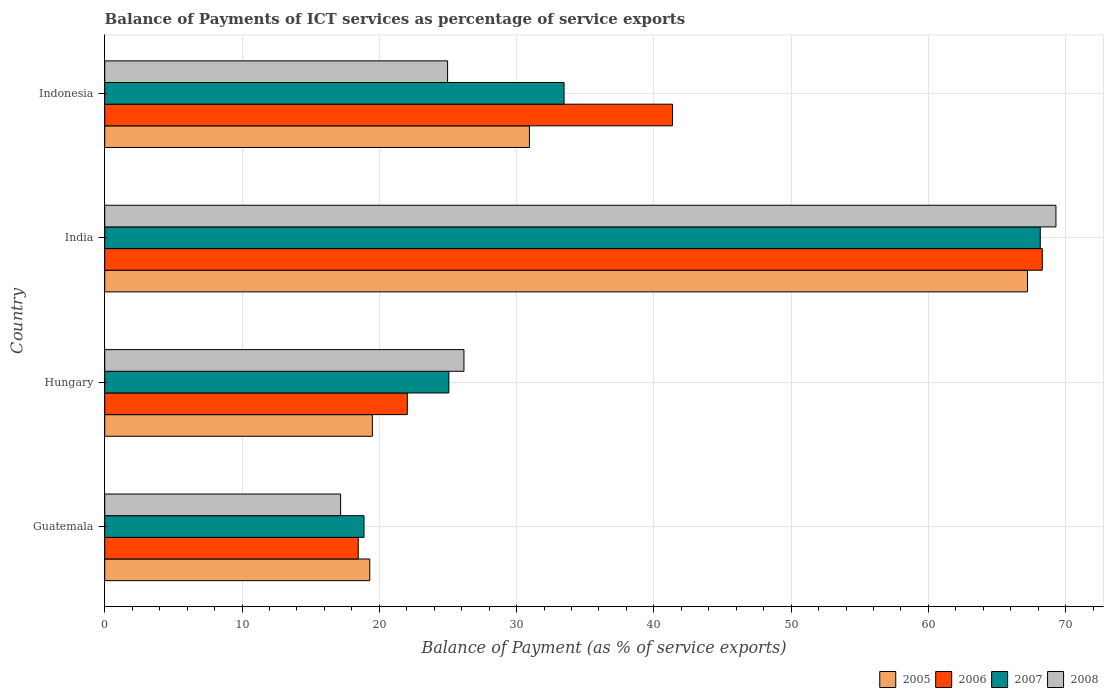How many groups of bars are there?
Provide a succinct answer. 4. Are the number of bars per tick equal to the number of legend labels?
Your response must be concise. Yes. Are the number of bars on each tick of the Y-axis equal?
Provide a short and direct response. Yes. How many bars are there on the 4th tick from the top?
Provide a short and direct response. 4. What is the label of the 2nd group of bars from the top?
Give a very brief answer. India. In how many cases, is the number of bars for a given country not equal to the number of legend labels?
Ensure brevity in your answer.  0. What is the balance of payments of ICT services in 2005 in Indonesia?
Make the answer very short. 30.94. Across all countries, what is the maximum balance of payments of ICT services in 2005?
Give a very brief answer. 67.22. Across all countries, what is the minimum balance of payments of ICT services in 2008?
Make the answer very short. 17.18. In which country was the balance of payments of ICT services in 2005 maximum?
Make the answer very short. India. In which country was the balance of payments of ICT services in 2008 minimum?
Your answer should be compact. Guatemala. What is the total balance of payments of ICT services in 2006 in the graph?
Your response must be concise. 150.17. What is the difference between the balance of payments of ICT services in 2007 in Hungary and that in India?
Ensure brevity in your answer.  -43.08. What is the difference between the balance of payments of ICT services in 2005 in India and the balance of payments of ICT services in 2007 in Guatemala?
Offer a very short reply. 48.33. What is the average balance of payments of ICT services in 2006 per country?
Provide a short and direct response. 37.54. What is the difference between the balance of payments of ICT services in 2007 and balance of payments of ICT services in 2005 in Indonesia?
Offer a very short reply. 2.52. What is the ratio of the balance of payments of ICT services in 2006 in Hungary to that in Indonesia?
Provide a succinct answer. 0.53. Is the balance of payments of ICT services in 2008 in Guatemala less than that in India?
Provide a short and direct response. Yes. What is the difference between the highest and the second highest balance of payments of ICT services in 2006?
Ensure brevity in your answer.  26.93. What is the difference between the highest and the lowest balance of payments of ICT services in 2008?
Your response must be concise. 52.11. In how many countries, is the balance of payments of ICT services in 2008 greater than the average balance of payments of ICT services in 2008 taken over all countries?
Ensure brevity in your answer.  1. What does the 2nd bar from the top in Indonesia represents?
Ensure brevity in your answer.  2007. How many bars are there?
Give a very brief answer. 16. How many countries are there in the graph?
Your answer should be compact. 4. What is the difference between two consecutive major ticks on the X-axis?
Your response must be concise. 10. Are the values on the major ticks of X-axis written in scientific E-notation?
Make the answer very short. No. Does the graph contain any zero values?
Your response must be concise. No. Where does the legend appear in the graph?
Ensure brevity in your answer.  Bottom right. How many legend labels are there?
Provide a succinct answer. 4. What is the title of the graph?
Make the answer very short. Balance of Payments of ICT services as percentage of service exports. Does "1979" appear as one of the legend labels in the graph?
Provide a succinct answer. No. What is the label or title of the X-axis?
Give a very brief answer. Balance of Payment (as % of service exports). What is the label or title of the Y-axis?
Offer a very short reply. Country. What is the Balance of Payment (as % of service exports) in 2005 in Guatemala?
Your answer should be compact. 19.31. What is the Balance of Payment (as % of service exports) in 2006 in Guatemala?
Give a very brief answer. 18.47. What is the Balance of Payment (as % of service exports) of 2007 in Guatemala?
Offer a very short reply. 18.89. What is the Balance of Payment (as % of service exports) of 2008 in Guatemala?
Give a very brief answer. 17.18. What is the Balance of Payment (as % of service exports) of 2005 in Hungary?
Ensure brevity in your answer.  19.5. What is the Balance of Payment (as % of service exports) in 2006 in Hungary?
Your response must be concise. 22.04. What is the Balance of Payment (as % of service exports) in 2007 in Hungary?
Provide a short and direct response. 25.07. What is the Balance of Payment (as % of service exports) of 2008 in Hungary?
Make the answer very short. 26.17. What is the Balance of Payment (as % of service exports) in 2005 in India?
Your answer should be compact. 67.22. What is the Balance of Payment (as % of service exports) in 2006 in India?
Your answer should be compact. 68.29. What is the Balance of Payment (as % of service exports) of 2007 in India?
Provide a short and direct response. 68.15. What is the Balance of Payment (as % of service exports) of 2008 in India?
Offer a terse response. 69.29. What is the Balance of Payment (as % of service exports) in 2005 in Indonesia?
Your answer should be compact. 30.94. What is the Balance of Payment (as % of service exports) of 2006 in Indonesia?
Keep it short and to the point. 41.36. What is the Balance of Payment (as % of service exports) of 2007 in Indonesia?
Your response must be concise. 33.46. What is the Balance of Payment (as % of service exports) of 2008 in Indonesia?
Offer a very short reply. 24.98. Across all countries, what is the maximum Balance of Payment (as % of service exports) in 2005?
Your response must be concise. 67.22. Across all countries, what is the maximum Balance of Payment (as % of service exports) of 2006?
Give a very brief answer. 68.29. Across all countries, what is the maximum Balance of Payment (as % of service exports) of 2007?
Offer a very short reply. 68.15. Across all countries, what is the maximum Balance of Payment (as % of service exports) in 2008?
Ensure brevity in your answer.  69.29. Across all countries, what is the minimum Balance of Payment (as % of service exports) of 2005?
Your answer should be compact. 19.31. Across all countries, what is the minimum Balance of Payment (as % of service exports) of 2006?
Your answer should be compact. 18.47. Across all countries, what is the minimum Balance of Payment (as % of service exports) in 2007?
Provide a short and direct response. 18.89. Across all countries, what is the minimum Balance of Payment (as % of service exports) in 2008?
Your answer should be very brief. 17.18. What is the total Balance of Payment (as % of service exports) in 2005 in the graph?
Your answer should be compact. 136.96. What is the total Balance of Payment (as % of service exports) in 2006 in the graph?
Offer a terse response. 150.17. What is the total Balance of Payment (as % of service exports) of 2007 in the graph?
Your answer should be compact. 145.57. What is the total Balance of Payment (as % of service exports) in 2008 in the graph?
Ensure brevity in your answer.  137.62. What is the difference between the Balance of Payment (as % of service exports) in 2005 in Guatemala and that in Hungary?
Provide a succinct answer. -0.19. What is the difference between the Balance of Payment (as % of service exports) of 2006 in Guatemala and that in Hungary?
Offer a very short reply. -3.57. What is the difference between the Balance of Payment (as % of service exports) of 2007 in Guatemala and that in Hungary?
Provide a short and direct response. -6.18. What is the difference between the Balance of Payment (as % of service exports) in 2008 in Guatemala and that in Hungary?
Your answer should be very brief. -8.98. What is the difference between the Balance of Payment (as % of service exports) in 2005 in Guatemala and that in India?
Your answer should be compact. -47.91. What is the difference between the Balance of Payment (as % of service exports) in 2006 in Guatemala and that in India?
Offer a very short reply. -49.83. What is the difference between the Balance of Payment (as % of service exports) in 2007 in Guatemala and that in India?
Give a very brief answer. -49.26. What is the difference between the Balance of Payment (as % of service exports) in 2008 in Guatemala and that in India?
Your answer should be compact. -52.11. What is the difference between the Balance of Payment (as % of service exports) of 2005 in Guatemala and that in Indonesia?
Provide a succinct answer. -11.63. What is the difference between the Balance of Payment (as % of service exports) in 2006 in Guatemala and that in Indonesia?
Your answer should be compact. -22.89. What is the difference between the Balance of Payment (as % of service exports) of 2007 in Guatemala and that in Indonesia?
Keep it short and to the point. -14.57. What is the difference between the Balance of Payment (as % of service exports) of 2008 in Guatemala and that in Indonesia?
Keep it short and to the point. -7.79. What is the difference between the Balance of Payment (as % of service exports) of 2005 in Hungary and that in India?
Your answer should be compact. -47.72. What is the difference between the Balance of Payment (as % of service exports) of 2006 in Hungary and that in India?
Offer a very short reply. -46.25. What is the difference between the Balance of Payment (as % of service exports) of 2007 in Hungary and that in India?
Ensure brevity in your answer.  -43.08. What is the difference between the Balance of Payment (as % of service exports) of 2008 in Hungary and that in India?
Your answer should be compact. -43.12. What is the difference between the Balance of Payment (as % of service exports) of 2005 in Hungary and that in Indonesia?
Ensure brevity in your answer.  -11.44. What is the difference between the Balance of Payment (as % of service exports) of 2006 in Hungary and that in Indonesia?
Keep it short and to the point. -19.32. What is the difference between the Balance of Payment (as % of service exports) of 2007 in Hungary and that in Indonesia?
Make the answer very short. -8.39. What is the difference between the Balance of Payment (as % of service exports) of 2008 in Hungary and that in Indonesia?
Provide a succinct answer. 1.19. What is the difference between the Balance of Payment (as % of service exports) of 2005 in India and that in Indonesia?
Make the answer very short. 36.28. What is the difference between the Balance of Payment (as % of service exports) in 2006 in India and that in Indonesia?
Offer a very short reply. 26.93. What is the difference between the Balance of Payment (as % of service exports) in 2007 in India and that in Indonesia?
Your answer should be very brief. 34.69. What is the difference between the Balance of Payment (as % of service exports) in 2008 in India and that in Indonesia?
Offer a terse response. 44.31. What is the difference between the Balance of Payment (as % of service exports) of 2005 in Guatemala and the Balance of Payment (as % of service exports) of 2006 in Hungary?
Provide a succinct answer. -2.73. What is the difference between the Balance of Payment (as % of service exports) of 2005 in Guatemala and the Balance of Payment (as % of service exports) of 2007 in Hungary?
Give a very brief answer. -5.76. What is the difference between the Balance of Payment (as % of service exports) in 2005 in Guatemala and the Balance of Payment (as % of service exports) in 2008 in Hungary?
Provide a short and direct response. -6.86. What is the difference between the Balance of Payment (as % of service exports) in 2006 in Guatemala and the Balance of Payment (as % of service exports) in 2007 in Hungary?
Give a very brief answer. -6.6. What is the difference between the Balance of Payment (as % of service exports) of 2006 in Guatemala and the Balance of Payment (as % of service exports) of 2008 in Hungary?
Keep it short and to the point. -7.7. What is the difference between the Balance of Payment (as % of service exports) of 2007 in Guatemala and the Balance of Payment (as % of service exports) of 2008 in Hungary?
Offer a very short reply. -7.28. What is the difference between the Balance of Payment (as % of service exports) in 2005 in Guatemala and the Balance of Payment (as % of service exports) in 2006 in India?
Make the answer very short. -48.99. What is the difference between the Balance of Payment (as % of service exports) in 2005 in Guatemala and the Balance of Payment (as % of service exports) in 2007 in India?
Offer a very short reply. -48.84. What is the difference between the Balance of Payment (as % of service exports) of 2005 in Guatemala and the Balance of Payment (as % of service exports) of 2008 in India?
Offer a very short reply. -49.98. What is the difference between the Balance of Payment (as % of service exports) in 2006 in Guatemala and the Balance of Payment (as % of service exports) in 2007 in India?
Your answer should be compact. -49.68. What is the difference between the Balance of Payment (as % of service exports) in 2006 in Guatemala and the Balance of Payment (as % of service exports) in 2008 in India?
Your response must be concise. -50.82. What is the difference between the Balance of Payment (as % of service exports) in 2007 in Guatemala and the Balance of Payment (as % of service exports) in 2008 in India?
Your answer should be very brief. -50.4. What is the difference between the Balance of Payment (as % of service exports) in 2005 in Guatemala and the Balance of Payment (as % of service exports) in 2006 in Indonesia?
Provide a short and direct response. -22.05. What is the difference between the Balance of Payment (as % of service exports) in 2005 in Guatemala and the Balance of Payment (as % of service exports) in 2007 in Indonesia?
Offer a very short reply. -14.15. What is the difference between the Balance of Payment (as % of service exports) of 2005 in Guatemala and the Balance of Payment (as % of service exports) of 2008 in Indonesia?
Your response must be concise. -5.67. What is the difference between the Balance of Payment (as % of service exports) in 2006 in Guatemala and the Balance of Payment (as % of service exports) in 2007 in Indonesia?
Provide a succinct answer. -14.99. What is the difference between the Balance of Payment (as % of service exports) in 2006 in Guatemala and the Balance of Payment (as % of service exports) in 2008 in Indonesia?
Provide a short and direct response. -6.51. What is the difference between the Balance of Payment (as % of service exports) of 2007 in Guatemala and the Balance of Payment (as % of service exports) of 2008 in Indonesia?
Offer a terse response. -6.09. What is the difference between the Balance of Payment (as % of service exports) of 2005 in Hungary and the Balance of Payment (as % of service exports) of 2006 in India?
Give a very brief answer. -48.8. What is the difference between the Balance of Payment (as % of service exports) of 2005 in Hungary and the Balance of Payment (as % of service exports) of 2007 in India?
Offer a very short reply. -48.65. What is the difference between the Balance of Payment (as % of service exports) of 2005 in Hungary and the Balance of Payment (as % of service exports) of 2008 in India?
Offer a terse response. -49.79. What is the difference between the Balance of Payment (as % of service exports) of 2006 in Hungary and the Balance of Payment (as % of service exports) of 2007 in India?
Offer a terse response. -46.11. What is the difference between the Balance of Payment (as % of service exports) in 2006 in Hungary and the Balance of Payment (as % of service exports) in 2008 in India?
Ensure brevity in your answer.  -47.25. What is the difference between the Balance of Payment (as % of service exports) of 2007 in Hungary and the Balance of Payment (as % of service exports) of 2008 in India?
Your answer should be compact. -44.22. What is the difference between the Balance of Payment (as % of service exports) of 2005 in Hungary and the Balance of Payment (as % of service exports) of 2006 in Indonesia?
Your answer should be compact. -21.87. What is the difference between the Balance of Payment (as % of service exports) in 2005 in Hungary and the Balance of Payment (as % of service exports) in 2007 in Indonesia?
Give a very brief answer. -13.96. What is the difference between the Balance of Payment (as % of service exports) in 2005 in Hungary and the Balance of Payment (as % of service exports) in 2008 in Indonesia?
Offer a terse response. -5.48. What is the difference between the Balance of Payment (as % of service exports) of 2006 in Hungary and the Balance of Payment (as % of service exports) of 2007 in Indonesia?
Give a very brief answer. -11.42. What is the difference between the Balance of Payment (as % of service exports) of 2006 in Hungary and the Balance of Payment (as % of service exports) of 2008 in Indonesia?
Provide a short and direct response. -2.94. What is the difference between the Balance of Payment (as % of service exports) of 2007 in Hungary and the Balance of Payment (as % of service exports) of 2008 in Indonesia?
Ensure brevity in your answer.  0.09. What is the difference between the Balance of Payment (as % of service exports) in 2005 in India and the Balance of Payment (as % of service exports) in 2006 in Indonesia?
Offer a terse response. 25.86. What is the difference between the Balance of Payment (as % of service exports) of 2005 in India and the Balance of Payment (as % of service exports) of 2007 in Indonesia?
Make the answer very short. 33.76. What is the difference between the Balance of Payment (as % of service exports) of 2005 in India and the Balance of Payment (as % of service exports) of 2008 in Indonesia?
Keep it short and to the point. 42.24. What is the difference between the Balance of Payment (as % of service exports) in 2006 in India and the Balance of Payment (as % of service exports) in 2007 in Indonesia?
Make the answer very short. 34.84. What is the difference between the Balance of Payment (as % of service exports) in 2006 in India and the Balance of Payment (as % of service exports) in 2008 in Indonesia?
Your response must be concise. 43.32. What is the difference between the Balance of Payment (as % of service exports) in 2007 in India and the Balance of Payment (as % of service exports) in 2008 in Indonesia?
Offer a very short reply. 43.17. What is the average Balance of Payment (as % of service exports) of 2005 per country?
Provide a succinct answer. 34.24. What is the average Balance of Payment (as % of service exports) of 2006 per country?
Ensure brevity in your answer.  37.54. What is the average Balance of Payment (as % of service exports) in 2007 per country?
Your answer should be compact. 36.39. What is the average Balance of Payment (as % of service exports) of 2008 per country?
Ensure brevity in your answer.  34.4. What is the difference between the Balance of Payment (as % of service exports) in 2005 and Balance of Payment (as % of service exports) in 2006 in Guatemala?
Your answer should be compact. 0.84. What is the difference between the Balance of Payment (as % of service exports) of 2005 and Balance of Payment (as % of service exports) of 2007 in Guatemala?
Your response must be concise. 0.42. What is the difference between the Balance of Payment (as % of service exports) in 2005 and Balance of Payment (as % of service exports) in 2008 in Guatemala?
Offer a terse response. 2.12. What is the difference between the Balance of Payment (as % of service exports) in 2006 and Balance of Payment (as % of service exports) in 2007 in Guatemala?
Your response must be concise. -0.42. What is the difference between the Balance of Payment (as % of service exports) in 2006 and Balance of Payment (as % of service exports) in 2008 in Guatemala?
Offer a terse response. 1.28. What is the difference between the Balance of Payment (as % of service exports) of 2007 and Balance of Payment (as % of service exports) of 2008 in Guatemala?
Make the answer very short. 1.71. What is the difference between the Balance of Payment (as % of service exports) in 2005 and Balance of Payment (as % of service exports) in 2006 in Hungary?
Your response must be concise. -2.55. What is the difference between the Balance of Payment (as % of service exports) in 2005 and Balance of Payment (as % of service exports) in 2007 in Hungary?
Make the answer very short. -5.57. What is the difference between the Balance of Payment (as % of service exports) of 2005 and Balance of Payment (as % of service exports) of 2008 in Hungary?
Provide a short and direct response. -6.67. What is the difference between the Balance of Payment (as % of service exports) in 2006 and Balance of Payment (as % of service exports) in 2007 in Hungary?
Keep it short and to the point. -3.03. What is the difference between the Balance of Payment (as % of service exports) in 2006 and Balance of Payment (as % of service exports) in 2008 in Hungary?
Offer a terse response. -4.13. What is the difference between the Balance of Payment (as % of service exports) in 2007 and Balance of Payment (as % of service exports) in 2008 in Hungary?
Your answer should be very brief. -1.1. What is the difference between the Balance of Payment (as % of service exports) of 2005 and Balance of Payment (as % of service exports) of 2006 in India?
Keep it short and to the point. -1.08. What is the difference between the Balance of Payment (as % of service exports) of 2005 and Balance of Payment (as % of service exports) of 2007 in India?
Make the answer very short. -0.93. What is the difference between the Balance of Payment (as % of service exports) of 2005 and Balance of Payment (as % of service exports) of 2008 in India?
Keep it short and to the point. -2.07. What is the difference between the Balance of Payment (as % of service exports) of 2006 and Balance of Payment (as % of service exports) of 2007 in India?
Keep it short and to the point. 0.15. What is the difference between the Balance of Payment (as % of service exports) of 2006 and Balance of Payment (as % of service exports) of 2008 in India?
Provide a short and direct response. -0.99. What is the difference between the Balance of Payment (as % of service exports) in 2007 and Balance of Payment (as % of service exports) in 2008 in India?
Provide a succinct answer. -1.14. What is the difference between the Balance of Payment (as % of service exports) in 2005 and Balance of Payment (as % of service exports) in 2006 in Indonesia?
Your answer should be compact. -10.42. What is the difference between the Balance of Payment (as % of service exports) in 2005 and Balance of Payment (as % of service exports) in 2007 in Indonesia?
Keep it short and to the point. -2.52. What is the difference between the Balance of Payment (as % of service exports) in 2005 and Balance of Payment (as % of service exports) in 2008 in Indonesia?
Your response must be concise. 5.96. What is the difference between the Balance of Payment (as % of service exports) in 2006 and Balance of Payment (as % of service exports) in 2007 in Indonesia?
Make the answer very short. 7.9. What is the difference between the Balance of Payment (as % of service exports) of 2006 and Balance of Payment (as % of service exports) of 2008 in Indonesia?
Give a very brief answer. 16.39. What is the difference between the Balance of Payment (as % of service exports) of 2007 and Balance of Payment (as % of service exports) of 2008 in Indonesia?
Keep it short and to the point. 8.48. What is the ratio of the Balance of Payment (as % of service exports) in 2005 in Guatemala to that in Hungary?
Give a very brief answer. 0.99. What is the ratio of the Balance of Payment (as % of service exports) of 2006 in Guatemala to that in Hungary?
Ensure brevity in your answer.  0.84. What is the ratio of the Balance of Payment (as % of service exports) of 2007 in Guatemala to that in Hungary?
Make the answer very short. 0.75. What is the ratio of the Balance of Payment (as % of service exports) in 2008 in Guatemala to that in Hungary?
Provide a short and direct response. 0.66. What is the ratio of the Balance of Payment (as % of service exports) of 2005 in Guatemala to that in India?
Offer a terse response. 0.29. What is the ratio of the Balance of Payment (as % of service exports) in 2006 in Guatemala to that in India?
Keep it short and to the point. 0.27. What is the ratio of the Balance of Payment (as % of service exports) in 2007 in Guatemala to that in India?
Provide a short and direct response. 0.28. What is the ratio of the Balance of Payment (as % of service exports) of 2008 in Guatemala to that in India?
Offer a very short reply. 0.25. What is the ratio of the Balance of Payment (as % of service exports) of 2005 in Guatemala to that in Indonesia?
Offer a very short reply. 0.62. What is the ratio of the Balance of Payment (as % of service exports) in 2006 in Guatemala to that in Indonesia?
Make the answer very short. 0.45. What is the ratio of the Balance of Payment (as % of service exports) in 2007 in Guatemala to that in Indonesia?
Your response must be concise. 0.56. What is the ratio of the Balance of Payment (as % of service exports) of 2008 in Guatemala to that in Indonesia?
Offer a terse response. 0.69. What is the ratio of the Balance of Payment (as % of service exports) in 2005 in Hungary to that in India?
Give a very brief answer. 0.29. What is the ratio of the Balance of Payment (as % of service exports) in 2006 in Hungary to that in India?
Your answer should be very brief. 0.32. What is the ratio of the Balance of Payment (as % of service exports) of 2007 in Hungary to that in India?
Your answer should be compact. 0.37. What is the ratio of the Balance of Payment (as % of service exports) of 2008 in Hungary to that in India?
Offer a terse response. 0.38. What is the ratio of the Balance of Payment (as % of service exports) of 2005 in Hungary to that in Indonesia?
Make the answer very short. 0.63. What is the ratio of the Balance of Payment (as % of service exports) of 2006 in Hungary to that in Indonesia?
Keep it short and to the point. 0.53. What is the ratio of the Balance of Payment (as % of service exports) in 2007 in Hungary to that in Indonesia?
Provide a short and direct response. 0.75. What is the ratio of the Balance of Payment (as % of service exports) in 2008 in Hungary to that in Indonesia?
Keep it short and to the point. 1.05. What is the ratio of the Balance of Payment (as % of service exports) in 2005 in India to that in Indonesia?
Keep it short and to the point. 2.17. What is the ratio of the Balance of Payment (as % of service exports) of 2006 in India to that in Indonesia?
Keep it short and to the point. 1.65. What is the ratio of the Balance of Payment (as % of service exports) of 2007 in India to that in Indonesia?
Keep it short and to the point. 2.04. What is the ratio of the Balance of Payment (as % of service exports) in 2008 in India to that in Indonesia?
Ensure brevity in your answer.  2.77. What is the difference between the highest and the second highest Balance of Payment (as % of service exports) of 2005?
Keep it short and to the point. 36.28. What is the difference between the highest and the second highest Balance of Payment (as % of service exports) of 2006?
Your answer should be very brief. 26.93. What is the difference between the highest and the second highest Balance of Payment (as % of service exports) of 2007?
Offer a terse response. 34.69. What is the difference between the highest and the second highest Balance of Payment (as % of service exports) of 2008?
Offer a terse response. 43.12. What is the difference between the highest and the lowest Balance of Payment (as % of service exports) in 2005?
Your answer should be very brief. 47.91. What is the difference between the highest and the lowest Balance of Payment (as % of service exports) of 2006?
Make the answer very short. 49.83. What is the difference between the highest and the lowest Balance of Payment (as % of service exports) in 2007?
Offer a terse response. 49.26. What is the difference between the highest and the lowest Balance of Payment (as % of service exports) of 2008?
Ensure brevity in your answer.  52.11. 